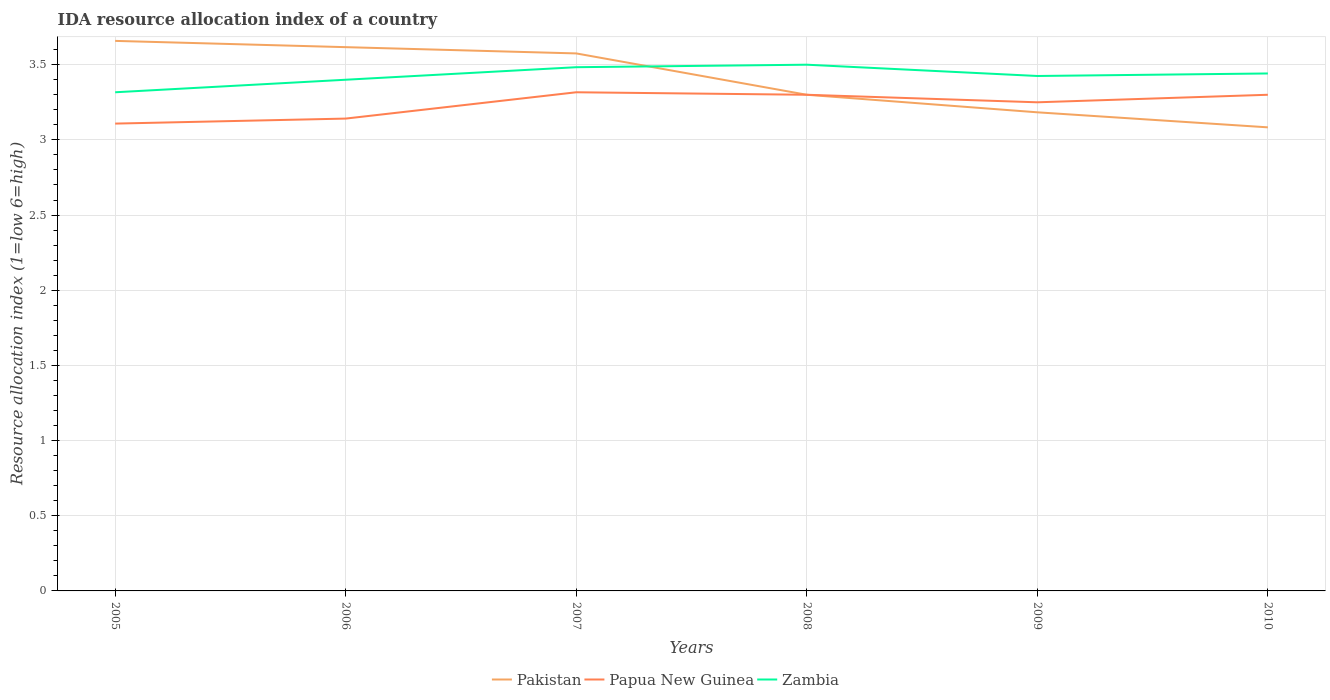Across all years, what is the maximum IDA resource allocation index in Papua New Guinea?
Provide a short and direct response. 3.11. What is the total IDA resource allocation index in Pakistan in the graph?
Provide a short and direct response. 0.08. What is the difference between the highest and the second highest IDA resource allocation index in Papua New Guinea?
Your response must be concise. 0.21. How many lines are there?
Offer a very short reply. 3. How many years are there in the graph?
Your answer should be compact. 6. What is the difference between two consecutive major ticks on the Y-axis?
Keep it short and to the point. 0.5. Are the values on the major ticks of Y-axis written in scientific E-notation?
Provide a short and direct response. No. Where does the legend appear in the graph?
Offer a very short reply. Bottom center. How many legend labels are there?
Give a very brief answer. 3. How are the legend labels stacked?
Give a very brief answer. Horizontal. What is the title of the graph?
Your answer should be compact. IDA resource allocation index of a country. Does "Cameroon" appear as one of the legend labels in the graph?
Make the answer very short. No. What is the label or title of the Y-axis?
Ensure brevity in your answer.  Resource allocation index (1=low 6=high). What is the Resource allocation index (1=low 6=high) in Pakistan in 2005?
Your response must be concise. 3.66. What is the Resource allocation index (1=low 6=high) in Papua New Guinea in 2005?
Make the answer very short. 3.11. What is the Resource allocation index (1=low 6=high) of Zambia in 2005?
Offer a very short reply. 3.32. What is the Resource allocation index (1=low 6=high) of Pakistan in 2006?
Your answer should be compact. 3.62. What is the Resource allocation index (1=low 6=high) of Papua New Guinea in 2006?
Provide a short and direct response. 3.14. What is the Resource allocation index (1=low 6=high) in Zambia in 2006?
Provide a succinct answer. 3.4. What is the Resource allocation index (1=low 6=high) in Pakistan in 2007?
Offer a terse response. 3.58. What is the Resource allocation index (1=low 6=high) in Papua New Guinea in 2007?
Your answer should be very brief. 3.32. What is the Resource allocation index (1=low 6=high) in Zambia in 2007?
Offer a terse response. 3.48. What is the Resource allocation index (1=low 6=high) in Pakistan in 2008?
Your answer should be very brief. 3.3. What is the Resource allocation index (1=low 6=high) of Pakistan in 2009?
Your response must be concise. 3.18. What is the Resource allocation index (1=low 6=high) of Papua New Guinea in 2009?
Provide a succinct answer. 3.25. What is the Resource allocation index (1=low 6=high) of Zambia in 2009?
Your response must be concise. 3.42. What is the Resource allocation index (1=low 6=high) of Pakistan in 2010?
Provide a short and direct response. 3.08. What is the Resource allocation index (1=low 6=high) in Zambia in 2010?
Provide a short and direct response. 3.44. Across all years, what is the maximum Resource allocation index (1=low 6=high) in Pakistan?
Offer a very short reply. 3.66. Across all years, what is the maximum Resource allocation index (1=low 6=high) of Papua New Guinea?
Ensure brevity in your answer.  3.32. Across all years, what is the minimum Resource allocation index (1=low 6=high) in Pakistan?
Ensure brevity in your answer.  3.08. Across all years, what is the minimum Resource allocation index (1=low 6=high) in Papua New Guinea?
Your answer should be very brief. 3.11. Across all years, what is the minimum Resource allocation index (1=low 6=high) of Zambia?
Your response must be concise. 3.32. What is the total Resource allocation index (1=low 6=high) of Pakistan in the graph?
Keep it short and to the point. 20.42. What is the total Resource allocation index (1=low 6=high) of Papua New Guinea in the graph?
Ensure brevity in your answer.  19.42. What is the total Resource allocation index (1=low 6=high) of Zambia in the graph?
Your answer should be very brief. 20.57. What is the difference between the Resource allocation index (1=low 6=high) of Pakistan in 2005 and that in 2006?
Provide a short and direct response. 0.04. What is the difference between the Resource allocation index (1=low 6=high) in Papua New Guinea in 2005 and that in 2006?
Provide a short and direct response. -0.03. What is the difference between the Resource allocation index (1=low 6=high) in Zambia in 2005 and that in 2006?
Provide a short and direct response. -0.08. What is the difference between the Resource allocation index (1=low 6=high) of Pakistan in 2005 and that in 2007?
Ensure brevity in your answer.  0.08. What is the difference between the Resource allocation index (1=low 6=high) of Papua New Guinea in 2005 and that in 2007?
Ensure brevity in your answer.  -0.21. What is the difference between the Resource allocation index (1=low 6=high) of Zambia in 2005 and that in 2007?
Make the answer very short. -0.17. What is the difference between the Resource allocation index (1=low 6=high) of Pakistan in 2005 and that in 2008?
Your answer should be very brief. 0.36. What is the difference between the Resource allocation index (1=low 6=high) in Papua New Guinea in 2005 and that in 2008?
Keep it short and to the point. -0.19. What is the difference between the Resource allocation index (1=low 6=high) of Zambia in 2005 and that in 2008?
Keep it short and to the point. -0.18. What is the difference between the Resource allocation index (1=low 6=high) in Pakistan in 2005 and that in 2009?
Provide a succinct answer. 0.47. What is the difference between the Resource allocation index (1=low 6=high) of Papua New Guinea in 2005 and that in 2009?
Your response must be concise. -0.14. What is the difference between the Resource allocation index (1=low 6=high) of Zambia in 2005 and that in 2009?
Offer a terse response. -0.11. What is the difference between the Resource allocation index (1=low 6=high) in Pakistan in 2005 and that in 2010?
Your answer should be compact. 0.57. What is the difference between the Resource allocation index (1=low 6=high) in Papua New Guinea in 2005 and that in 2010?
Your answer should be compact. -0.19. What is the difference between the Resource allocation index (1=low 6=high) of Zambia in 2005 and that in 2010?
Give a very brief answer. -0.12. What is the difference between the Resource allocation index (1=low 6=high) of Pakistan in 2006 and that in 2007?
Your response must be concise. 0.04. What is the difference between the Resource allocation index (1=low 6=high) in Papua New Guinea in 2006 and that in 2007?
Make the answer very short. -0.17. What is the difference between the Resource allocation index (1=low 6=high) in Zambia in 2006 and that in 2007?
Provide a short and direct response. -0.08. What is the difference between the Resource allocation index (1=low 6=high) in Pakistan in 2006 and that in 2008?
Your answer should be compact. 0.32. What is the difference between the Resource allocation index (1=low 6=high) in Papua New Guinea in 2006 and that in 2008?
Keep it short and to the point. -0.16. What is the difference between the Resource allocation index (1=low 6=high) of Zambia in 2006 and that in 2008?
Offer a terse response. -0.1. What is the difference between the Resource allocation index (1=low 6=high) of Pakistan in 2006 and that in 2009?
Your answer should be compact. 0.43. What is the difference between the Resource allocation index (1=low 6=high) in Papua New Guinea in 2006 and that in 2009?
Keep it short and to the point. -0.11. What is the difference between the Resource allocation index (1=low 6=high) of Zambia in 2006 and that in 2009?
Keep it short and to the point. -0.03. What is the difference between the Resource allocation index (1=low 6=high) in Pakistan in 2006 and that in 2010?
Your response must be concise. 0.53. What is the difference between the Resource allocation index (1=low 6=high) of Papua New Guinea in 2006 and that in 2010?
Provide a short and direct response. -0.16. What is the difference between the Resource allocation index (1=low 6=high) of Zambia in 2006 and that in 2010?
Provide a short and direct response. -0.04. What is the difference between the Resource allocation index (1=low 6=high) in Pakistan in 2007 and that in 2008?
Your response must be concise. 0.28. What is the difference between the Resource allocation index (1=low 6=high) of Papua New Guinea in 2007 and that in 2008?
Give a very brief answer. 0.02. What is the difference between the Resource allocation index (1=low 6=high) in Zambia in 2007 and that in 2008?
Provide a succinct answer. -0.02. What is the difference between the Resource allocation index (1=low 6=high) in Pakistan in 2007 and that in 2009?
Offer a very short reply. 0.39. What is the difference between the Resource allocation index (1=low 6=high) of Papua New Guinea in 2007 and that in 2009?
Offer a very short reply. 0.07. What is the difference between the Resource allocation index (1=low 6=high) in Zambia in 2007 and that in 2009?
Offer a terse response. 0.06. What is the difference between the Resource allocation index (1=low 6=high) in Pakistan in 2007 and that in 2010?
Your response must be concise. 0.49. What is the difference between the Resource allocation index (1=low 6=high) in Papua New Guinea in 2007 and that in 2010?
Your answer should be very brief. 0.02. What is the difference between the Resource allocation index (1=low 6=high) of Zambia in 2007 and that in 2010?
Keep it short and to the point. 0.04. What is the difference between the Resource allocation index (1=low 6=high) in Pakistan in 2008 and that in 2009?
Your answer should be very brief. 0.12. What is the difference between the Resource allocation index (1=low 6=high) in Papua New Guinea in 2008 and that in 2009?
Your response must be concise. 0.05. What is the difference between the Resource allocation index (1=low 6=high) of Zambia in 2008 and that in 2009?
Your answer should be very brief. 0.07. What is the difference between the Resource allocation index (1=low 6=high) of Pakistan in 2008 and that in 2010?
Your answer should be very brief. 0.22. What is the difference between the Resource allocation index (1=low 6=high) in Zambia in 2008 and that in 2010?
Your answer should be very brief. 0.06. What is the difference between the Resource allocation index (1=low 6=high) in Pakistan in 2009 and that in 2010?
Keep it short and to the point. 0.1. What is the difference between the Resource allocation index (1=low 6=high) of Zambia in 2009 and that in 2010?
Offer a terse response. -0.02. What is the difference between the Resource allocation index (1=low 6=high) of Pakistan in 2005 and the Resource allocation index (1=low 6=high) of Papua New Guinea in 2006?
Offer a very short reply. 0.52. What is the difference between the Resource allocation index (1=low 6=high) in Pakistan in 2005 and the Resource allocation index (1=low 6=high) in Zambia in 2006?
Ensure brevity in your answer.  0.26. What is the difference between the Resource allocation index (1=low 6=high) of Papua New Guinea in 2005 and the Resource allocation index (1=low 6=high) of Zambia in 2006?
Ensure brevity in your answer.  -0.29. What is the difference between the Resource allocation index (1=low 6=high) in Pakistan in 2005 and the Resource allocation index (1=low 6=high) in Papua New Guinea in 2007?
Keep it short and to the point. 0.34. What is the difference between the Resource allocation index (1=low 6=high) of Pakistan in 2005 and the Resource allocation index (1=low 6=high) of Zambia in 2007?
Give a very brief answer. 0.17. What is the difference between the Resource allocation index (1=low 6=high) in Papua New Guinea in 2005 and the Resource allocation index (1=low 6=high) in Zambia in 2007?
Provide a succinct answer. -0.38. What is the difference between the Resource allocation index (1=low 6=high) in Pakistan in 2005 and the Resource allocation index (1=low 6=high) in Papua New Guinea in 2008?
Provide a succinct answer. 0.36. What is the difference between the Resource allocation index (1=low 6=high) of Pakistan in 2005 and the Resource allocation index (1=low 6=high) of Zambia in 2008?
Offer a very short reply. 0.16. What is the difference between the Resource allocation index (1=low 6=high) in Papua New Guinea in 2005 and the Resource allocation index (1=low 6=high) in Zambia in 2008?
Offer a very short reply. -0.39. What is the difference between the Resource allocation index (1=low 6=high) of Pakistan in 2005 and the Resource allocation index (1=low 6=high) of Papua New Guinea in 2009?
Your answer should be compact. 0.41. What is the difference between the Resource allocation index (1=low 6=high) in Pakistan in 2005 and the Resource allocation index (1=low 6=high) in Zambia in 2009?
Ensure brevity in your answer.  0.23. What is the difference between the Resource allocation index (1=low 6=high) of Papua New Guinea in 2005 and the Resource allocation index (1=low 6=high) of Zambia in 2009?
Ensure brevity in your answer.  -0.32. What is the difference between the Resource allocation index (1=low 6=high) of Pakistan in 2005 and the Resource allocation index (1=low 6=high) of Papua New Guinea in 2010?
Offer a terse response. 0.36. What is the difference between the Resource allocation index (1=low 6=high) of Pakistan in 2005 and the Resource allocation index (1=low 6=high) of Zambia in 2010?
Offer a terse response. 0.22. What is the difference between the Resource allocation index (1=low 6=high) of Papua New Guinea in 2005 and the Resource allocation index (1=low 6=high) of Zambia in 2010?
Your response must be concise. -0.33. What is the difference between the Resource allocation index (1=low 6=high) in Pakistan in 2006 and the Resource allocation index (1=low 6=high) in Papua New Guinea in 2007?
Provide a short and direct response. 0.3. What is the difference between the Resource allocation index (1=low 6=high) of Pakistan in 2006 and the Resource allocation index (1=low 6=high) of Zambia in 2007?
Your answer should be very brief. 0.13. What is the difference between the Resource allocation index (1=low 6=high) in Papua New Guinea in 2006 and the Resource allocation index (1=low 6=high) in Zambia in 2007?
Make the answer very short. -0.34. What is the difference between the Resource allocation index (1=low 6=high) of Pakistan in 2006 and the Resource allocation index (1=low 6=high) of Papua New Guinea in 2008?
Provide a succinct answer. 0.32. What is the difference between the Resource allocation index (1=low 6=high) in Pakistan in 2006 and the Resource allocation index (1=low 6=high) in Zambia in 2008?
Your response must be concise. 0.12. What is the difference between the Resource allocation index (1=low 6=high) in Papua New Guinea in 2006 and the Resource allocation index (1=low 6=high) in Zambia in 2008?
Your answer should be very brief. -0.36. What is the difference between the Resource allocation index (1=low 6=high) of Pakistan in 2006 and the Resource allocation index (1=low 6=high) of Papua New Guinea in 2009?
Your answer should be compact. 0.37. What is the difference between the Resource allocation index (1=low 6=high) of Pakistan in 2006 and the Resource allocation index (1=low 6=high) of Zambia in 2009?
Your answer should be compact. 0.19. What is the difference between the Resource allocation index (1=low 6=high) in Papua New Guinea in 2006 and the Resource allocation index (1=low 6=high) in Zambia in 2009?
Provide a short and direct response. -0.28. What is the difference between the Resource allocation index (1=low 6=high) of Pakistan in 2006 and the Resource allocation index (1=low 6=high) of Papua New Guinea in 2010?
Your answer should be very brief. 0.32. What is the difference between the Resource allocation index (1=low 6=high) in Pakistan in 2006 and the Resource allocation index (1=low 6=high) in Zambia in 2010?
Your answer should be compact. 0.17. What is the difference between the Resource allocation index (1=low 6=high) in Pakistan in 2007 and the Resource allocation index (1=low 6=high) in Papua New Guinea in 2008?
Provide a short and direct response. 0.28. What is the difference between the Resource allocation index (1=low 6=high) of Pakistan in 2007 and the Resource allocation index (1=low 6=high) of Zambia in 2008?
Ensure brevity in your answer.  0.07. What is the difference between the Resource allocation index (1=low 6=high) in Papua New Guinea in 2007 and the Resource allocation index (1=low 6=high) in Zambia in 2008?
Your answer should be very brief. -0.18. What is the difference between the Resource allocation index (1=low 6=high) in Pakistan in 2007 and the Resource allocation index (1=low 6=high) in Papua New Guinea in 2009?
Ensure brevity in your answer.  0.33. What is the difference between the Resource allocation index (1=low 6=high) of Papua New Guinea in 2007 and the Resource allocation index (1=low 6=high) of Zambia in 2009?
Ensure brevity in your answer.  -0.11. What is the difference between the Resource allocation index (1=low 6=high) of Pakistan in 2007 and the Resource allocation index (1=low 6=high) of Papua New Guinea in 2010?
Your response must be concise. 0.28. What is the difference between the Resource allocation index (1=low 6=high) in Pakistan in 2007 and the Resource allocation index (1=low 6=high) in Zambia in 2010?
Your response must be concise. 0.13. What is the difference between the Resource allocation index (1=low 6=high) of Papua New Guinea in 2007 and the Resource allocation index (1=low 6=high) of Zambia in 2010?
Ensure brevity in your answer.  -0.12. What is the difference between the Resource allocation index (1=low 6=high) in Pakistan in 2008 and the Resource allocation index (1=low 6=high) in Papua New Guinea in 2009?
Make the answer very short. 0.05. What is the difference between the Resource allocation index (1=low 6=high) of Pakistan in 2008 and the Resource allocation index (1=low 6=high) of Zambia in 2009?
Your answer should be compact. -0.12. What is the difference between the Resource allocation index (1=low 6=high) in Papua New Guinea in 2008 and the Resource allocation index (1=low 6=high) in Zambia in 2009?
Keep it short and to the point. -0.12. What is the difference between the Resource allocation index (1=low 6=high) of Pakistan in 2008 and the Resource allocation index (1=low 6=high) of Papua New Guinea in 2010?
Your answer should be very brief. 0. What is the difference between the Resource allocation index (1=low 6=high) in Pakistan in 2008 and the Resource allocation index (1=low 6=high) in Zambia in 2010?
Offer a terse response. -0.14. What is the difference between the Resource allocation index (1=low 6=high) of Papua New Guinea in 2008 and the Resource allocation index (1=low 6=high) of Zambia in 2010?
Offer a very short reply. -0.14. What is the difference between the Resource allocation index (1=low 6=high) of Pakistan in 2009 and the Resource allocation index (1=low 6=high) of Papua New Guinea in 2010?
Offer a very short reply. -0.12. What is the difference between the Resource allocation index (1=low 6=high) of Pakistan in 2009 and the Resource allocation index (1=low 6=high) of Zambia in 2010?
Offer a very short reply. -0.26. What is the difference between the Resource allocation index (1=low 6=high) of Papua New Guinea in 2009 and the Resource allocation index (1=low 6=high) of Zambia in 2010?
Make the answer very short. -0.19. What is the average Resource allocation index (1=low 6=high) of Pakistan per year?
Give a very brief answer. 3.4. What is the average Resource allocation index (1=low 6=high) of Papua New Guinea per year?
Provide a short and direct response. 3.24. What is the average Resource allocation index (1=low 6=high) in Zambia per year?
Your response must be concise. 3.43. In the year 2005, what is the difference between the Resource allocation index (1=low 6=high) in Pakistan and Resource allocation index (1=low 6=high) in Papua New Guinea?
Make the answer very short. 0.55. In the year 2005, what is the difference between the Resource allocation index (1=low 6=high) in Pakistan and Resource allocation index (1=low 6=high) in Zambia?
Keep it short and to the point. 0.34. In the year 2005, what is the difference between the Resource allocation index (1=low 6=high) of Papua New Guinea and Resource allocation index (1=low 6=high) of Zambia?
Keep it short and to the point. -0.21. In the year 2006, what is the difference between the Resource allocation index (1=low 6=high) in Pakistan and Resource allocation index (1=low 6=high) in Papua New Guinea?
Make the answer very short. 0.47. In the year 2006, what is the difference between the Resource allocation index (1=low 6=high) of Pakistan and Resource allocation index (1=low 6=high) of Zambia?
Give a very brief answer. 0.22. In the year 2006, what is the difference between the Resource allocation index (1=low 6=high) in Papua New Guinea and Resource allocation index (1=low 6=high) in Zambia?
Make the answer very short. -0.26. In the year 2007, what is the difference between the Resource allocation index (1=low 6=high) of Pakistan and Resource allocation index (1=low 6=high) of Papua New Guinea?
Provide a short and direct response. 0.26. In the year 2007, what is the difference between the Resource allocation index (1=low 6=high) in Pakistan and Resource allocation index (1=low 6=high) in Zambia?
Give a very brief answer. 0.09. In the year 2009, what is the difference between the Resource allocation index (1=low 6=high) in Pakistan and Resource allocation index (1=low 6=high) in Papua New Guinea?
Your response must be concise. -0.07. In the year 2009, what is the difference between the Resource allocation index (1=low 6=high) in Pakistan and Resource allocation index (1=low 6=high) in Zambia?
Your answer should be compact. -0.24. In the year 2009, what is the difference between the Resource allocation index (1=low 6=high) of Papua New Guinea and Resource allocation index (1=low 6=high) of Zambia?
Provide a short and direct response. -0.17. In the year 2010, what is the difference between the Resource allocation index (1=low 6=high) of Pakistan and Resource allocation index (1=low 6=high) of Papua New Guinea?
Ensure brevity in your answer.  -0.22. In the year 2010, what is the difference between the Resource allocation index (1=low 6=high) of Pakistan and Resource allocation index (1=low 6=high) of Zambia?
Provide a succinct answer. -0.36. In the year 2010, what is the difference between the Resource allocation index (1=low 6=high) of Papua New Guinea and Resource allocation index (1=low 6=high) of Zambia?
Provide a succinct answer. -0.14. What is the ratio of the Resource allocation index (1=low 6=high) in Pakistan in 2005 to that in 2006?
Your response must be concise. 1.01. What is the ratio of the Resource allocation index (1=low 6=high) of Zambia in 2005 to that in 2006?
Ensure brevity in your answer.  0.98. What is the ratio of the Resource allocation index (1=low 6=high) of Pakistan in 2005 to that in 2007?
Your answer should be very brief. 1.02. What is the ratio of the Resource allocation index (1=low 6=high) in Papua New Guinea in 2005 to that in 2007?
Your response must be concise. 0.94. What is the ratio of the Resource allocation index (1=low 6=high) of Zambia in 2005 to that in 2007?
Ensure brevity in your answer.  0.95. What is the ratio of the Resource allocation index (1=low 6=high) in Pakistan in 2005 to that in 2008?
Provide a short and direct response. 1.11. What is the ratio of the Resource allocation index (1=low 6=high) in Papua New Guinea in 2005 to that in 2008?
Your response must be concise. 0.94. What is the ratio of the Resource allocation index (1=low 6=high) of Zambia in 2005 to that in 2008?
Your response must be concise. 0.95. What is the ratio of the Resource allocation index (1=low 6=high) in Pakistan in 2005 to that in 2009?
Offer a terse response. 1.15. What is the ratio of the Resource allocation index (1=low 6=high) of Papua New Guinea in 2005 to that in 2009?
Your answer should be very brief. 0.96. What is the ratio of the Resource allocation index (1=low 6=high) in Zambia in 2005 to that in 2009?
Your answer should be compact. 0.97. What is the ratio of the Resource allocation index (1=low 6=high) in Pakistan in 2005 to that in 2010?
Provide a succinct answer. 1.19. What is the ratio of the Resource allocation index (1=low 6=high) of Papua New Guinea in 2005 to that in 2010?
Make the answer very short. 0.94. What is the ratio of the Resource allocation index (1=low 6=high) of Zambia in 2005 to that in 2010?
Provide a short and direct response. 0.96. What is the ratio of the Resource allocation index (1=low 6=high) in Pakistan in 2006 to that in 2007?
Make the answer very short. 1.01. What is the ratio of the Resource allocation index (1=low 6=high) in Papua New Guinea in 2006 to that in 2007?
Offer a very short reply. 0.95. What is the ratio of the Resource allocation index (1=low 6=high) in Zambia in 2006 to that in 2007?
Your response must be concise. 0.98. What is the ratio of the Resource allocation index (1=low 6=high) in Pakistan in 2006 to that in 2008?
Offer a very short reply. 1.1. What is the ratio of the Resource allocation index (1=low 6=high) in Papua New Guinea in 2006 to that in 2008?
Make the answer very short. 0.95. What is the ratio of the Resource allocation index (1=low 6=high) of Zambia in 2006 to that in 2008?
Ensure brevity in your answer.  0.97. What is the ratio of the Resource allocation index (1=low 6=high) of Pakistan in 2006 to that in 2009?
Provide a short and direct response. 1.14. What is the ratio of the Resource allocation index (1=low 6=high) in Papua New Guinea in 2006 to that in 2009?
Offer a very short reply. 0.97. What is the ratio of the Resource allocation index (1=low 6=high) in Pakistan in 2006 to that in 2010?
Your answer should be compact. 1.17. What is the ratio of the Resource allocation index (1=low 6=high) in Papua New Guinea in 2006 to that in 2010?
Your answer should be compact. 0.95. What is the ratio of the Resource allocation index (1=low 6=high) of Zambia in 2006 to that in 2010?
Keep it short and to the point. 0.99. What is the ratio of the Resource allocation index (1=low 6=high) of Pakistan in 2007 to that in 2009?
Make the answer very short. 1.12. What is the ratio of the Resource allocation index (1=low 6=high) in Papua New Guinea in 2007 to that in 2009?
Your answer should be compact. 1.02. What is the ratio of the Resource allocation index (1=low 6=high) of Zambia in 2007 to that in 2009?
Your answer should be very brief. 1.02. What is the ratio of the Resource allocation index (1=low 6=high) of Pakistan in 2007 to that in 2010?
Make the answer very short. 1.16. What is the ratio of the Resource allocation index (1=low 6=high) in Papua New Guinea in 2007 to that in 2010?
Give a very brief answer. 1.01. What is the ratio of the Resource allocation index (1=low 6=high) of Zambia in 2007 to that in 2010?
Offer a terse response. 1.01. What is the ratio of the Resource allocation index (1=low 6=high) of Pakistan in 2008 to that in 2009?
Your answer should be compact. 1.04. What is the ratio of the Resource allocation index (1=low 6=high) of Papua New Guinea in 2008 to that in 2009?
Provide a short and direct response. 1.02. What is the ratio of the Resource allocation index (1=low 6=high) of Zambia in 2008 to that in 2009?
Give a very brief answer. 1.02. What is the ratio of the Resource allocation index (1=low 6=high) in Pakistan in 2008 to that in 2010?
Your response must be concise. 1.07. What is the ratio of the Resource allocation index (1=low 6=high) in Zambia in 2008 to that in 2010?
Your response must be concise. 1.02. What is the ratio of the Resource allocation index (1=low 6=high) in Pakistan in 2009 to that in 2010?
Your answer should be very brief. 1.03. What is the ratio of the Resource allocation index (1=low 6=high) in Zambia in 2009 to that in 2010?
Offer a very short reply. 1. What is the difference between the highest and the second highest Resource allocation index (1=low 6=high) in Pakistan?
Provide a short and direct response. 0.04. What is the difference between the highest and the second highest Resource allocation index (1=low 6=high) in Papua New Guinea?
Ensure brevity in your answer.  0.02. What is the difference between the highest and the second highest Resource allocation index (1=low 6=high) in Zambia?
Your answer should be compact. 0.02. What is the difference between the highest and the lowest Resource allocation index (1=low 6=high) of Pakistan?
Your response must be concise. 0.57. What is the difference between the highest and the lowest Resource allocation index (1=low 6=high) in Papua New Guinea?
Provide a succinct answer. 0.21. What is the difference between the highest and the lowest Resource allocation index (1=low 6=high) in Zambia?
Your answer should be very brief. 0.18. 